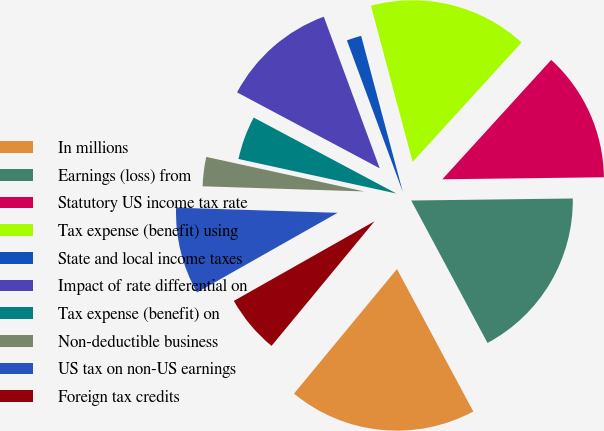Convert chart to OTSL. <chart><loc_0><loc_0><loc_500><loc_500><pie_chart><fcel>In millions<fcel>Earnings (loss) from<fcel>Statutory US income tax rate<fcel>Tax expense (benefit) using<fcel>State and local income taxes<fcel>Impact of rate differential on<fcel>Tax expense (benefit) on<fcel>Non-deductible business<fcel>US tax on non-US earnings<fcel>Foreign tax credits<nl><fcel>18.82%<fcel>17.37%<fcel>13.03%<fcel>15.92%<fcel>1.47%<fcel>11.59%<fcel>4.36%<fcel>2.92%<fcel>8.7%<fcel>5.81%<nl></chart> 